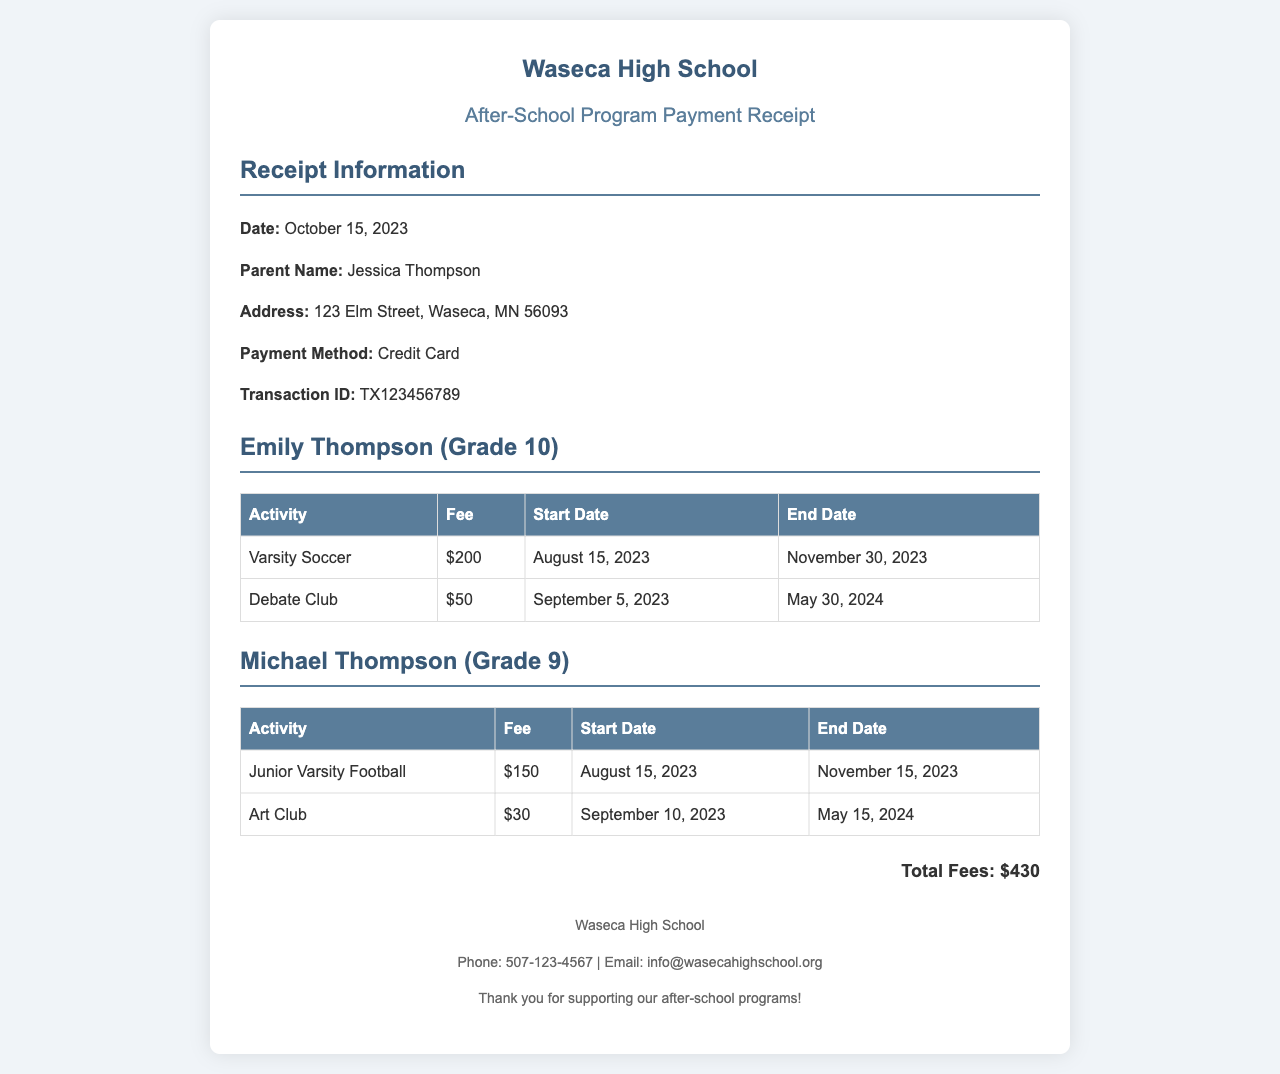What is the date of the receipt? The date of the receipt is clearly listed in the document as October 15, 2023.
Answer: October 15, 2023 Who is the parent listed on the receipt? The name of the parent is mentioned in the receipt information section as Jessica Thompson.
Answer: Jessica Thompson What is the total fees amount? The total fees is summarized at the bottom of the document as $430.
Answer: $430 What is the fee for Varsity Soccer? The fee for Varsity Soccer is stated in the table under Emily Thompson's activities.
Answer: $200 What are the start and end dates for Junior Varsity Football? The document provides the start and end dates for Junior Varsity Football, which are August 15, 2023, and November 15, 2023, respectively.
Answer: August 15, 2023 - November 15, 2023 How many activities are listed for Emily Thompson? The number of activities listed under Emily Thompson are counted from the table.
Answer: 2 What payment method was used? The payment method is specified in the receipt information as Credit Card.
Answer: Credit Card Which club begins in September for Michael Thompson? The document lists the activities for Michael Thompson, identifying which club begins in September.
Answer: Art Club 